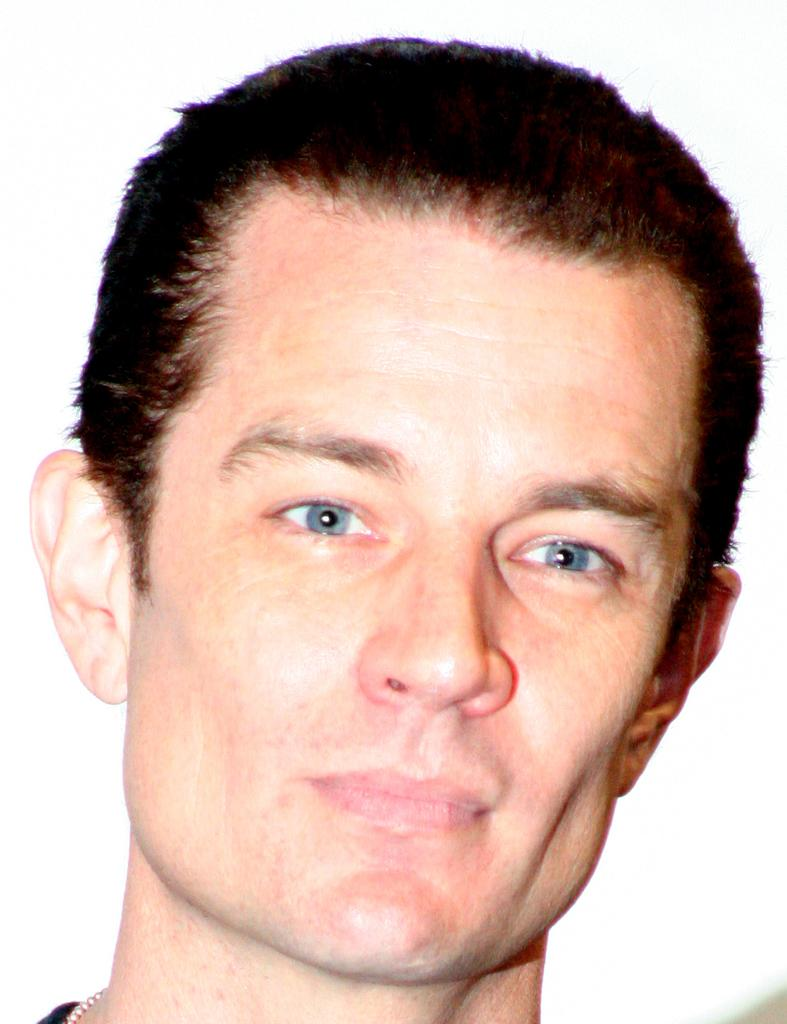What is the main subject of the image? The main subject of the image is a man's face. What type of town can be seen in the background of the image? There is no town visible in the image; it only features a man's face. What is the goat doing in the image? There is no goat present in the image. What is the texture of the butter in the image? There is no butter present in the image. 